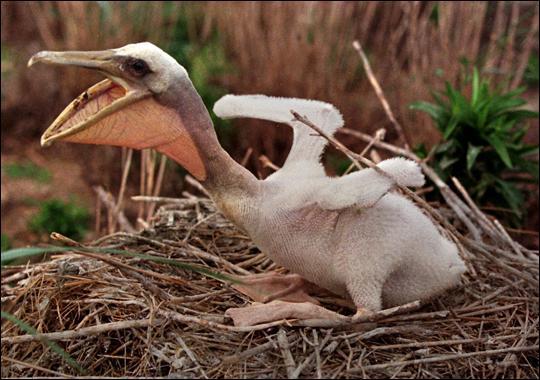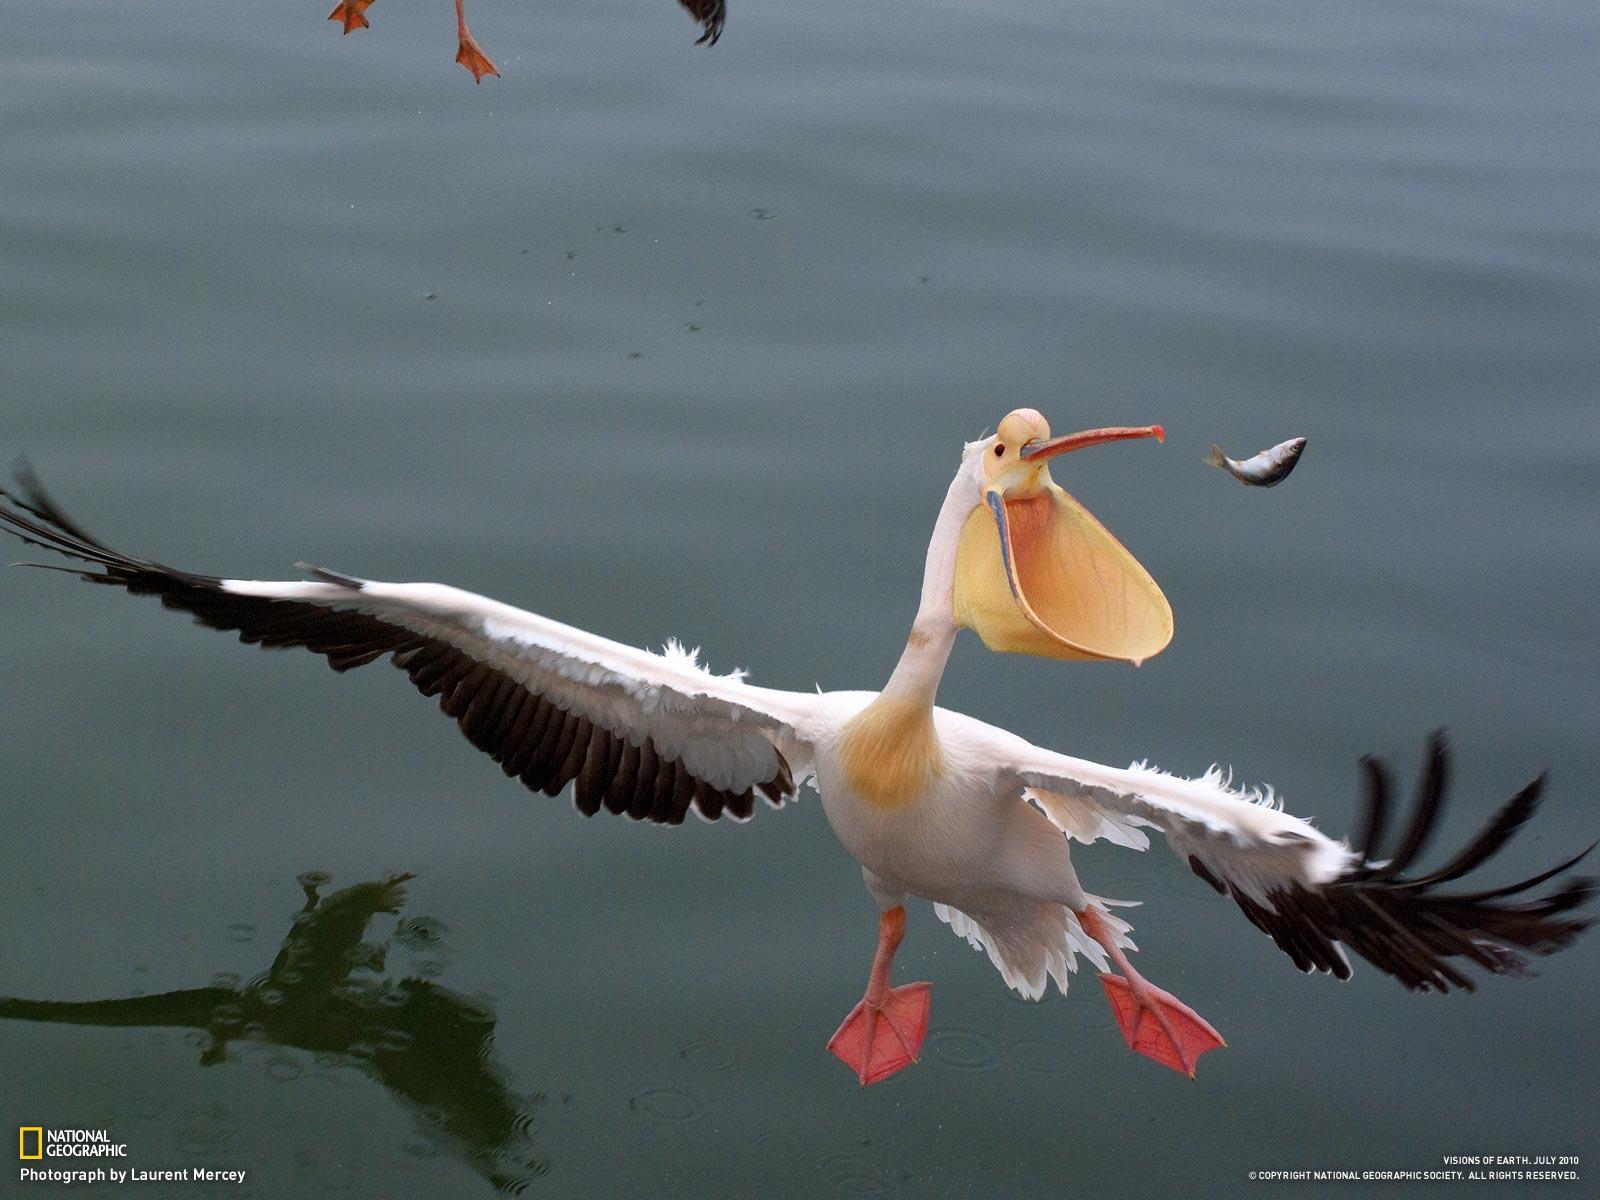The first image is the image on the left, the second image is the image on the right. Assess this claim about the two images: "An image shows a nest that includes a pelican with an open mouth in it.". Correct or not? Answer yes or no. Yes. The first image is the image on the left, the second image is the image on the right. Given the left and right images, does the statement "The bird in the image on the right is in a wet area." hold true? Answer yes or no. Yes. 